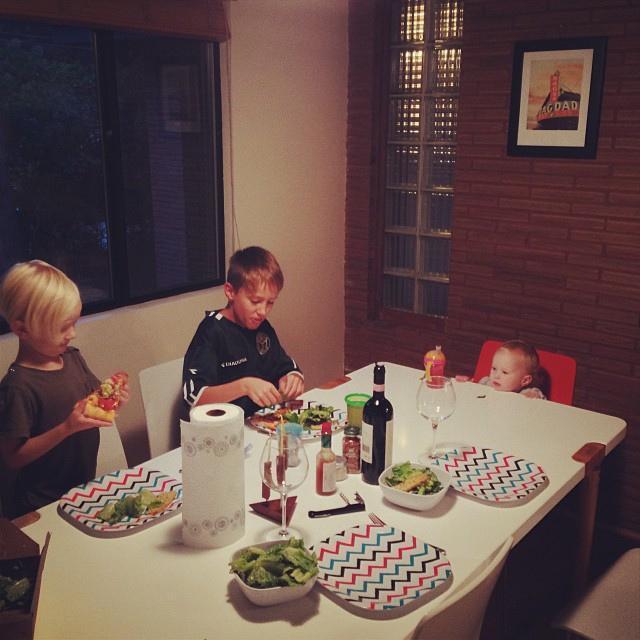How many people are shown?
Give a very brief answer. 3. How many bowls are in the picture?
Give a very brief answer. 2. How many chairs can you see?
Give a very brief answer. 3. How many people are in the picture?
Give a very brief answer. 3. 